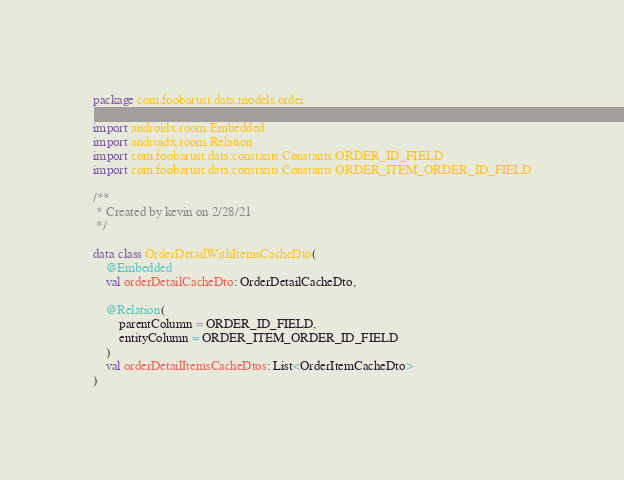Convert code to text. <code><loc_0><loc_0><loc_500><loc_500><_Kotlin_>package com.foobarust.data.models.order

import androidx.room.Embedded
import androidx.room.Relation
import com.foobarust.data.constants.Constants.ORDER_ID_FIELD
import com.foobarust.data.constants.Constants.ORDER_ITEM_ORDER_ID_FIELD

/**
 * Created by kevin on 2/28/21
 */

data class OrderDetailWithItemsCacheDto(
    @Embedded
    val orderDetailCacheDto: OrderDetailCacheDto,

    @Relation(
        parentColumn = ORDER_ID_FIELD,
        entityColumn = ORDER_ITEM_ORDER_ID_FIELD
    )
    val orderDetailItemsCacheDtos: List<OrderItemCacheDto>
)</code> 